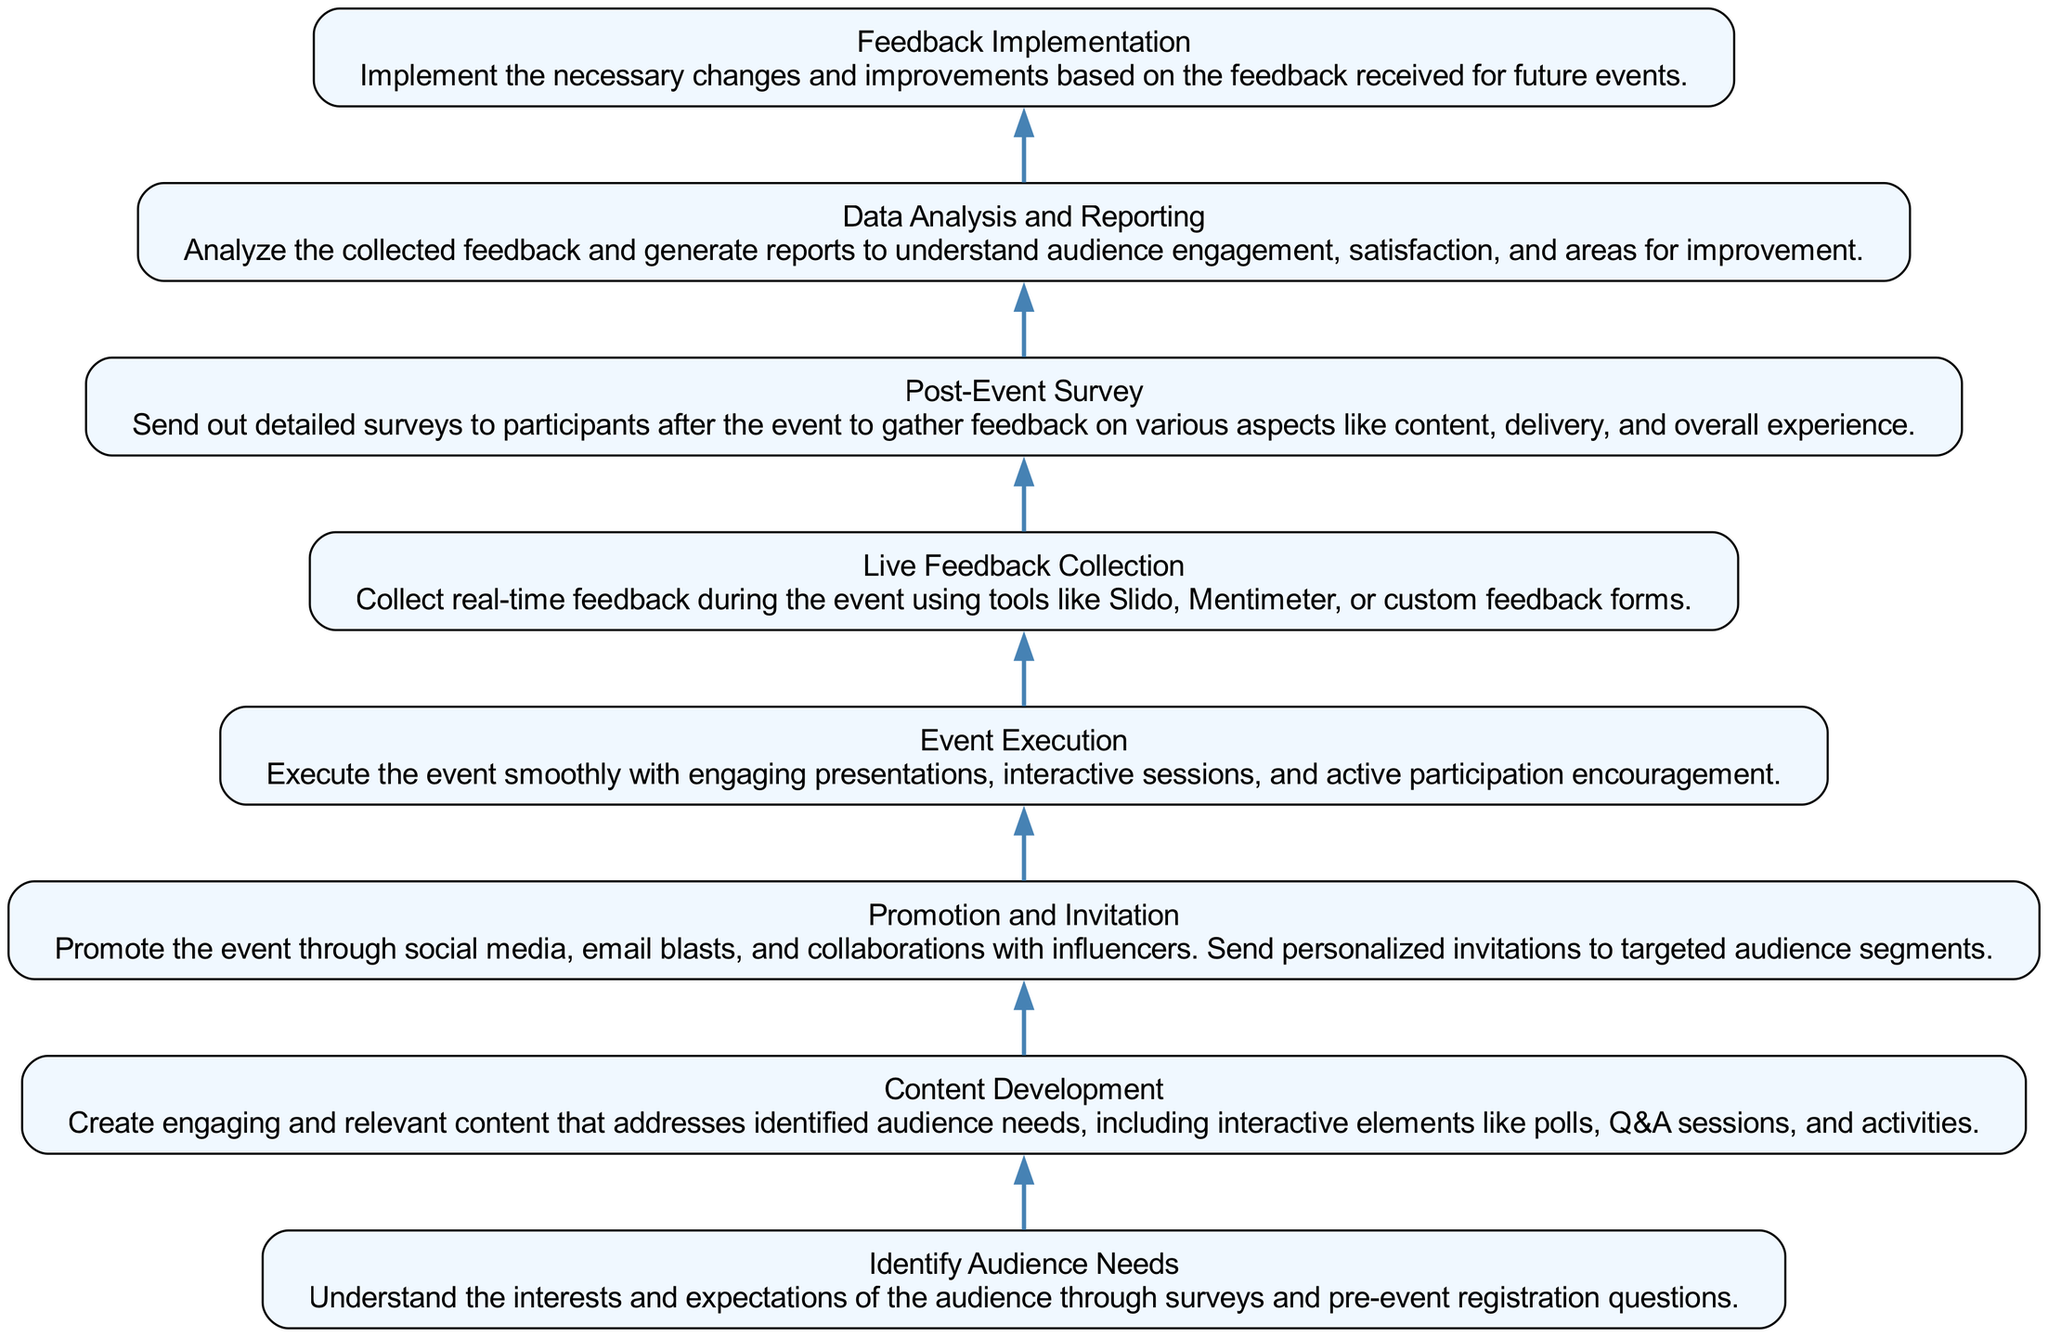What is the first step in the process? The first step in the process is labeled "Identify Audience Needs." By tracing from the bottom of the diagram, it's the node with no previous connections indicating it is the beginning.
Answer: Identify Audience Needs How many total steps are there in the process? Counting the flow chart elements from top to bottom, there are eight steps, each represented as a node.
Answer: Eight What follows "Event Execution"? Examining the node for "Event Execution," the next step indicated in the diagram is "Live Feedback Collection." This connection shows the flow from one step to the next.
Answer: Live Feedback Collection Which step involves analyzing feedback? The step that involves analyzing feedback is "Data Analysis and Reporting." This node specifically denotes the action of understanding collected feedback.
Answer: Data Analysis and Reporting What is the last step in the process? The last step in the diagram is "Feedback Implementation," which is the final node without any subsequent links, indicating it concludes the process.
Answer: Feedback Implementation How many nodes are there that lead to "Content Development"? Looking at the connections, there is one node that leads to "Content Development," and that node is "Identify Audience Needs."
Answer: One What is the relationship between "Live Feedback Collection" and "Post-Event Survey"? Between "Live Feedback Collection" and "Post-Event Survey," the relationship is sequential in nature, where "Live Feedback Collection" directly leads to "Post-Event Survey."
Answer: Sequential What type of tools are used during "Live Feedback Collection"? The tools used during "Live Feedback Collection" can be identified as Slido, Mentimeter, or custom feedback forms, as described in the relevant node.
Answer: Slido, Mentimeter, custom feedback forms 